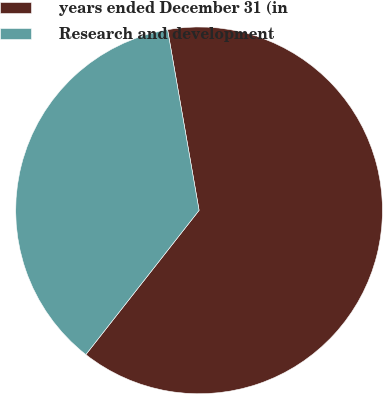Convert chart to OTSL. <chart><loc_0><loc_0><loc_500><loc_500><pie_chart><fcel>years ended December 31 (in<fcel>Research and development<nl><fcel>63.34%<fcel>36.66%<nl></chart> 